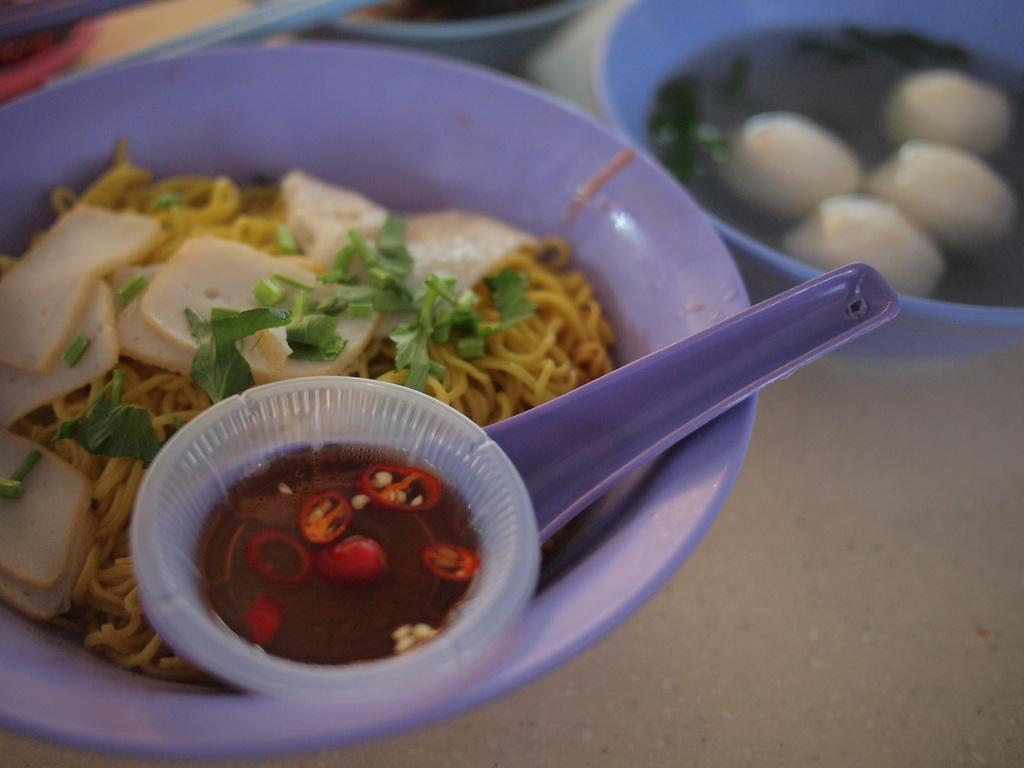What type of furniture is present in the image? There is a table in the image. What is on the table in the image? There are bowls containing food on the table. What accompanies the food in the bowls? There is sauce in the bowls on the table. How many mice can be seen helping to prepare the food in the image? There are no mice present in the image, and they are not involved in preparing the food. 